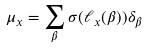<formula> <loc_0><loc_0><loc_500><loc_500>\mu _ { x } = \sum _ { \beta } \sigma ( \ell _ { x } ( \beta ) ) \delta _ { \beta }</formula> 